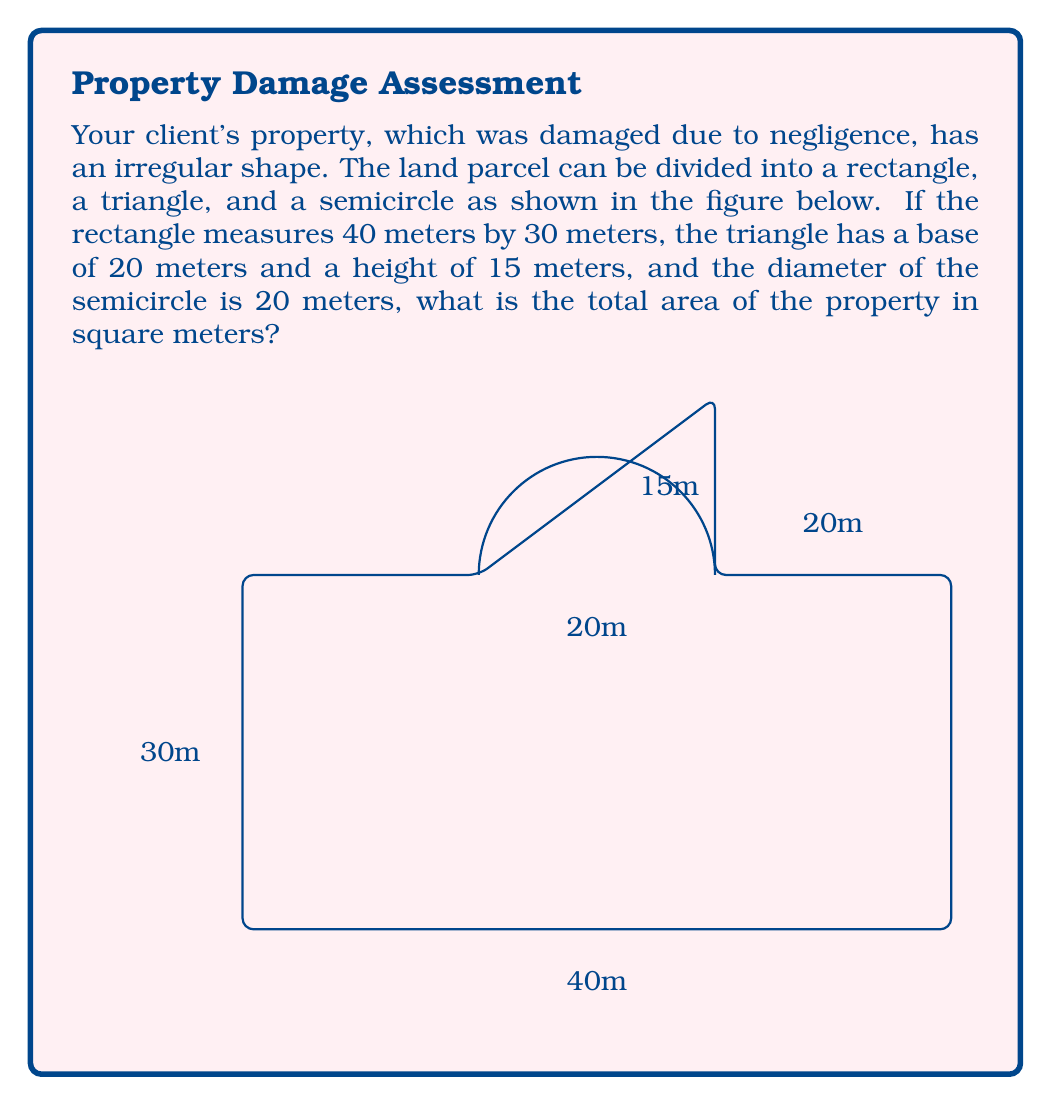Provide a solution to this math problem. To calculate the total area of the irregularly shaped land parcel, we need to sum the areas of its constituent parts:

1. Rectangle:
   Area = length × width
   $A_r = 40 \text{ m} \times 30 \text{ m} = 1200 \text{ m}^2$

2. Triangle:
   Area = $\frac{1}{2} \times$ base × height
   $A_t = \frac{1}{2} \times 20 \text{ m} \times 15 \text{ m} = 150 \text{ m}^2$

3. Semicircle:
   Area = $\frac{1}{2} \times \pi r^2$, where $r$ is the radius (half the diameter)
   $r = 10 \text{ m}$ (since the diameter is 20 m)
   $A_s = \frac{1}{2} \times \pi \times (10 \text{ m})^2 = 50\pi \text{ m}^2$

Total Area:
$$A_{total} = A_r + A_t + A_s$$
$$A_{total} = 1200 \text{ m}^2 + 150 \text{ m}^2 + 50\pi \text{ m}^2$$
$$A_{total} = 1350 \text{ m}^2 + 50\pi \text{ m}^2$$
$$A_{total} = 1350 \text{ m}^2 + 157.08 \text{ m}^2$$
$$A_{total} = 1507.08 \text{ m}^2$$

Rounding to the nearest square meter:
$$A_{total} \approx 1507 \text{ m}^2$$
Answer: 1507 m² 